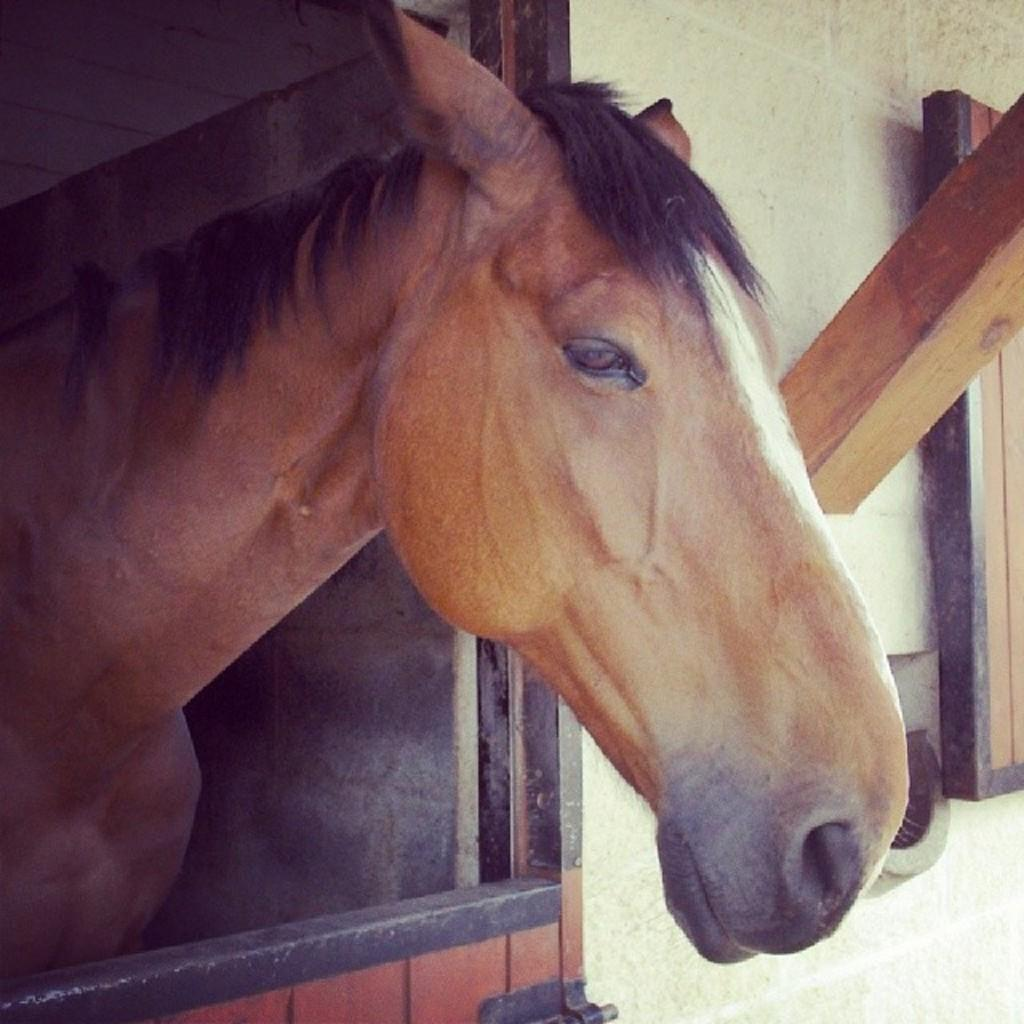What type of animal is in the image? There is a brown horse in the image. What is located below the horse? There is a wooden object below the horse. What can be seen attached to the wall in the right corner of the image? There are other wooden objects attached to the wall in the right corner of the image. Can you see a stranger interacting with the horse in the image? There is no stranger present in the image; it only features the brown horse and wooden objects. 